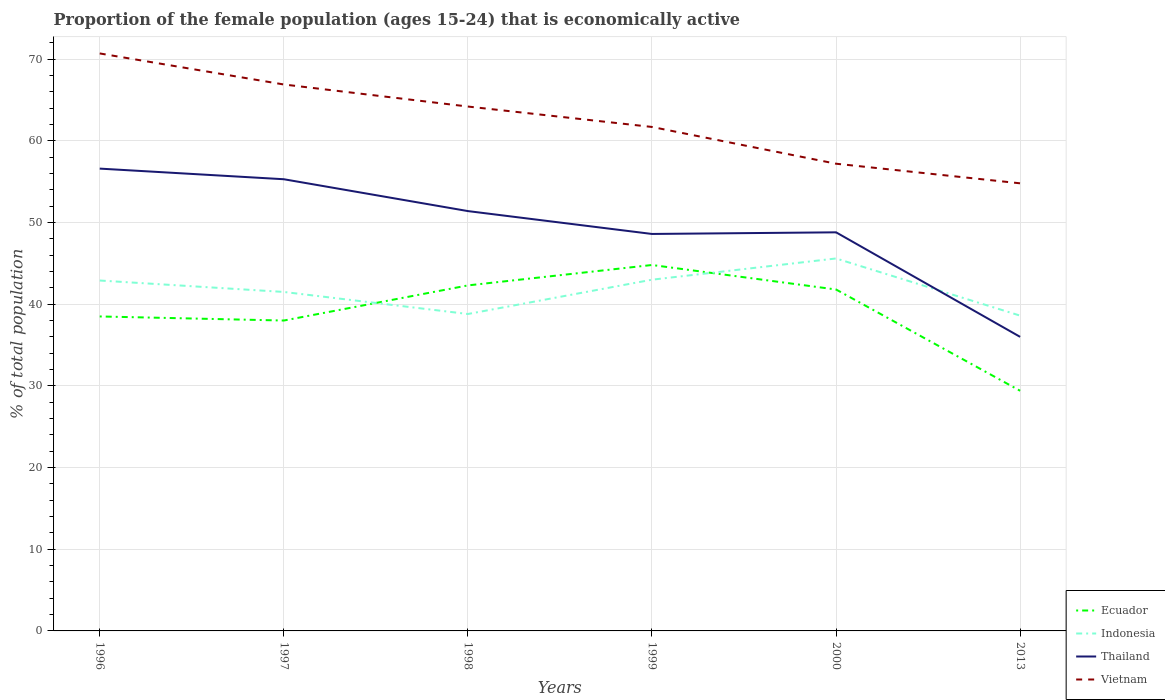Is the number of lines equal to the number of legend labels?
Ensure brevity in your answer.  Yes. Across all years, what is the maximum proportion of the female population that is economically active in Ecuador?
Provide a succinct answer. 29.4. What is the total proportion of the female population that is economically active in Ecuador in the graph?
Keep it short and to the point. -3.8. What is the difference between the highest and the second highest proportion of the female population that is economically active in Thailand?
Offer a very short reply. 20.6. How many years are there in the graph?
Provide a short and direct response. 6. What is the difference between two consecutive major ticks on the Y-axis?
Ensure brevity in your answer.  10. Are the values on the major ticks of Y-axis written in scientific E-notation?
Offer a very short reply. No. Does the graph contain any zero values?
Your answer should be compact. No. Where does the legend appear in the graph?
Offer a very short reply. Bottom right. What is the title of the graph?
Provide a succinct answer. Proportion of the female population (ages 15-24) that is economically active. Does "Macedonia" appear as one of the legend labels in the graph?
Provide a short and direct response. No. What is the label or title of the X-axis?
Provide a short and direct response. Years. What is the label or title of the Y-axis?
Ensure brevity in your answer.  % of total population. What is the % of total population in Ecuador in 1996?
Give a very brief answer. 38.5. What is the % of total population of Indonesia in 1996?
Your answer should be compact. 42.9. What is the % of total population in Thailand in 1996?
Your answer should be very brief. 56.6. What is the % of total population of Vietnam in 1996?
Provide a short and direct response. 70.7. What is the % of total population in Indonesia in 1997?
Make the answer very short. 41.5. What is the % of total population of Thailand in 1997?
Your response must be concise. 55.3. What is the % of total population in Vietnam in 1997?
Provide a succinct answer. 66.9. What is the % of total population in Ecuador in 1998?
Keep it short and to the point. 42.3. What is the % of total population of Indonesia in 1998?
Give a very brief answer. 38.8. What is the % of total population of Thailand in 1998?
Your response must be concise. 51.4. What is the % of total population of Vietnam in 1998?
Give a very brief answer. 64.2. What is the % of total population in Ecuador in 1999?
Your answer should be compact. 44.8. What is the % of total population of Indonesia in 1999?
Offer a terse response. 43. What is the % of total population of Thailand in 1999?
Ensure brevity in your answer.  48.6. What is the % of total population in Vietnam in 1999?
Your response must be concise. 61.7. What is the % of total population of Ecuador in 2000?
Your answer should be very brief. 41.8. What is the % of total population of Indonesia in 2000?
Make the answer very short. 45.6. What is the % of total population in Thailand in 2000?
Provide a short and direct response. 48.8. What is the % of total population in Vietnam in 2000?
Your answer should be compact. 57.2. What is the % of total population in Ecuador in 2013?
Provide a succinct answer. 29.4. What is the % of total population of Indonesia in 2013?
Offer a terse response. 38.6. What is the % of total population of Vietnam in 2013?
Make the answer very short. 54.8. Across all years, what is the maximum % of total population in Ecuador?
Make the answer very short. 44.8. Across all years, what is the maximum % of total population in Indonesia?
Keep it short and to the point. 45.6. Across all years, what is the maximum % of total population of Thailand?
Ensure brevity in your answer.  56.6. Across all years, what is the maximum % of total population of Vietnam?
Your response must be concise. 70.7. Across all years, what is the minimum % of total population of Ecuador?
Ensure brevity in your answer.  29.4. Across all years, what is the minimum % of total population in Indonesia?
Your answer should be very brief. 38.6. Across all years, what is the minimum % of total population in Vietnam?
Ensure brevity in your answer.  54.8. What is the total % of total population of Ecuador in the graph?
Make the answer very short. 234.8. What is the total % of total population in Indonesia in the graph?
Offer a terse response. 250.4. What is the total % of total population of Thailand in the graph?
Keep it short and to the point. 296.7. What is the total % of total population of Vietnam in the graph?
Keep it short and to the point. 375.5. What is the difference between the % of total population of Ecuador in 1996 and that in 1997?
Your answer should be very brief. 0.5. What is the difference between the % of total population in Indonesia in 1996 and that in 1997?
Provide a short and direct response. 1.4. What is the difference between the % of total population of Vietnam in 1996 and that in 1997?
Your answer should be compact. 3.8. What is the difference between the % of total population of Ecuador in 1996 and that in 1998?
Offer a terse response. -3.8. What is the difference between the % of total population of Indonesia in 1996 and that in 1998?
Give a very brief answer. 4.1. What is the difference between the % of total population in Thailand in 1996 and that in 1998?
Keep it short and to the point. 5.2. What is the difference between the % of total population of Vietnam in 1996 and that in 1998?
Your response must be concise. 6.5. What is the difference between the % of total population of Thailand in 1996 and that in 1999?
Ensure brevity in your answer.  8. What is the difference between the % of total population of Vietnam in 1996 and that in 1999?
Make the answer very short. 9. What is the difference between the % of total population of Indonesia in 1996 and that in 2000?
Ensure brevity in your answer.  -2.7. What is the difference between the % of total population of Indonesia in 1996 and that in 2013?
Provide a succinct answer. 4.3. What is the difference between the % of total population of Thailand in 1996 and that in 2013?
Your answer should be compact. 20.6. What is the difference between the % of total population in Indonesia in 1997 and that in 1998?
Offer a very short reply. 2.7. What is the difference between the % of total population in Ecuador in 1997 and that in 1999?
Offer a very short reply. -6.8. What is the difference between the % of total population in Thailand in 1997 and that in 1999?
Ensure brevity in your answer.  6.7. What is the difference between the % of total population in Thailand in 1997 and that in 2000?
Offer a very short reply. 6.5. What is the difference between the % of total population of Vietnam in 1997 and that in 2000?
Offer a very short reply. 9.7. What is the difference between the % of total population in Ecuador in 1997 and that in 2013?
Provide a succinct answer. 8.6. What is the difference between the % of total population of Thailand in 1997 and that in 2013?
Your answer should be compact. 19.3. What is the difference between the % of total population in Indonesia in 1998 and that in 1999?
Ensure brevity in your answer.  -4.2. What is the difference between the % of total population of Thailand in 1998 and that in 1999?
Your response must be concise. 2.8. What is the difference between the % of total population in Vietnam in 1998 and that in 1999?
Offer a very short reply. 2.5. What is the difference between the % of total population in Ecuador in 1998 and that in 2000?
Your response must be concise. 0.5. What is the difference between the % of total population in Vietnam in 1998 and that in 2000?
Ensure brevity in your answer.  7. What is the difference between the % of total population of Indonesia in 1998 and that in 2013?
Give a very brief answer. 0.2. What is the difference between the % of total population in Thailand in 1998 and that in 2013?
Your answer should be compact. 15.4. What is the difference between the % of total population in Ecuador in 1999 and that in 2000?
Provide a short and direct response. 3. What is the difference between the % of total population in Indonesia in 1999 and that in 2000?
Provide a short and direct response. -2.6. What is the difference between the % of total population of Thailand in 1999 and that in 2000?
Your response must be concise. -0.2. What is the difference between the % of total population of Vietnam in 1999 and that in 2000?
Offer a very short reply. 4.5. What is the difference between the % of total population of Indonesia in 1999 and that in 2013?
Provide a short and direct response. 4.4. What is the difference between the % of total population in Ecuador in 2000 and that in 2013?
Ensure brevity in your answer.  12.4. What is the difference between the % of total population of Ecuador in 1996 and the % of total population of Thailand in 1997?
Ensure brevity in your answer.  -16.8. What is the difference between the % of total population in Ecuador in 1996 and the % of total population in Vietnam in 1997?
Provide a short and direct response. -28.4. What is the difference between the % of total population of Indonesia in 1996 and the % of total population of Thailand in 1997?
Offer a very short reply. -12.4. What is the difference between the % of total population in Indonesia in 1996 and the % of total population in Vietnam in 1997?
Offer a very short reply. -24. What is the difference between the % of total population in Thailand in 1996 and the % of total population in Vietnam in 1997?
Make the answer very short. -10.3. What is the difference between the % of total population of Ecuador in 1996 and the % of total population of Indonesia in 1998?
Your answer should be compact. -0.3. What is the difference between the % of total population in Ecuador in 1996 and the % of total population in Vietnam in 1998?
Offer a very short reply. -25.7. What is the difference between the % of total population in Indonesia in 1996 and the % of total population in Thailand in 1998?
Provide a short and direct response. -8.5. What is the difference between the % of total population in Indonesia in 1996 and the % of total population in Vietnam in 1998?
Keep it short and to the point. -21.3. What is the difference between the % of total population of Thailand in 1996 and the % of total population of Vietnam in 1998?
Offer a very short reply. -7.6. What is the difference between the % of total population in Ecuador in 1996 and the % of total population in Indonesia in 1999?
Offer a very short reply. -4.5. What is the difference between the % of total population in Ecuador in 1996 and the % of total population in Vietnam in 1999?
Make the answer very short. -23.2. What is the difference between the % of total population in Indonesia in 1996 and the % of total population in Vietnam in 1999?
Offer a terse response. -18.8. What is the difference between the % of total population in Thailand in 1996 and the % of total population in Vietnam in 1999?
Your answer should be very brief. -5.1. What is the difference between the % of total population in Ecuador in 1996 and the % of total population in Vietnam in 2000?
Ensure brevity in your answer.  -18.7. What is the difference between the % of total population in Indonesia in 1996 and the % of total population in Vietnam in 2000?
Offer a very short reply. -14.3. What is the difference between the % of total population of Thailand in 1996 and the % of total population of Vietnam in 2000?
Make the answer very short. -0.6. What is the difference between the % of total population in Ecuador in 1996 and the % of total population in Vietnam in 2013?
Offer a terse response. -16.3. What is the difference between the % of total population of Indonesia in 1996 and the % of total population of Thailand in 2013?
Your answer should be very brief. 6.9. What is the difference between the % of total population in Indonesia in 1996 and the % of total population in Vietnam in 2013?
Offer a very short reply. -11.9. What is the difference between the % of total population in Ecuador in 1997 and the % of total population in Indonesia in 1998?
Your response must be concise. -0.8. What is the difference between the % of total population in Ecuador in 1997 and the % of total population in Thailand in 1998?
Provide a succinct answer. -13.4. What is the difference between the % of total population in Ecuador in 1997 and the % of total population in Vietnam in 1998?
Your answer should be compact. -26.2. What is the difference between the % of total population of Indonesia in 1997 and the % of total population of Thailand in 1998?
Ensure brevity in your answer.  -9.9. What is the difference between the % of total population of Indonesia in 1997 and the % of total population of Vietnam in 1998?
Offer a terse response. -22.7. What is the difference between the % of total population in Ecuador in 1997 and the % of total population in Vietnam in 1999?
Provide a short and direct response. -23.7. What is the difference between the % of total population in Indonesia in 1997 and the % of total population in Vietnam in 1999?
Give a very brief answer. -20.2. What is the difference between the % of total population of Ecuador in 1997 and the % of total population of Indonesia in 2000?
Provide a short and direct response. -7.6. What is the difference between the % of total population in Ecuador in 1997 and the % of total population in Vietnam in 2000?
Make the answer very short. -19.2. What is the difference between the % of total population in Indonesia in 1997 and the % of total population in Thailand in 2000?
Your answer should be compact. -7.3. What is the difference between the % of total population in Indonesia in 1997 and the % of total population in Vietnam in 2000?
Make the answer very short. -15.7. What is the difference between the % of total population in Thailand in 1997 and the % of total population in Vietnam in 2000?
Offer a very short reply. -1.9. What is the difference between the % of total population in Ecuador in 1997 and the % of total population in Indonesia in 2013?
Make the answer very short. -0.6. What is the difference between the % of total population in Ecuador in 1997 and the % of total population in Thailand in 2013?
Keep it short and to the point. 2. What is the difference between the % of total population of Ecuador in 1997 and the % of total population of Vietnam in 2013?
Ensure brevity in your answer.  -16.8. What is the difference between the % of total population in Indonesia in 1997 and the % of total population in Thailand in 2013?
Provide a succinct answer. 5.5. What is the difference between the % of total population of Indonesia in 1997 and the % of total population of Vietnam in 2013?
Your response must be concise. -13.3. What is the difference between the % of total population in Thailand in 1997 and the % of total population in Vietnam in 2013?
Keep it short and to the point. 0.5. What is the difference between the % of total population in Ecuador in 1998 and the % of total population in Vietnam in 1999?
Give a very brief answer. -19.4. What is the difference between the % of total population of Indonesia in 1998 and the % of total population of Thailand in 1999?
Keep it short and to the point. -9.8. What is the difference between the % of total population of Indonesia in 1998 and the % of total population of Vietnam in 1999?
Offer a terse response. -22.9. What is the difference between the % of total population of Ecuador in 1998 and the % of total population of Vietnam in 2000?
Your response must be concise. -14.9. What is the difference between the % of total population in Indonesia in 1998 and the % of total population in Vietnam in 2000?
Offer a terse response. -18.4. What is the difference between the % of total population of Ecuador in 1998 and the % of total population of Indonesia in 2013?
Give a very brief answer. 3.7. What is the difference between the % of total population in Ecuador in 1998 and the % of total population in Vietnam in 2013?
Your response must be concise. -12.5. What is the difference between the % of total population in Indonesia in 1998 and the % of total population in Thailand in 2013?
Give a very brief answer. 2.8. What is the difference between the % of total population in Indonesia in 1998 and the % of total population in Vietnam in 2013?
Make the answer very short. -16. What is the difference between the % of total population in Thailand in 1998 and the % of total population in Vietnam in 2013?
Ensure brevity in your answer.  -3.4. What is the difference between the % of total population of Ecuador in 1999 and the % of total population of Indonesia in 2000?
Provide a short and direct response. -0.8. What is the difference between the % of total population in Ecuador in 1999 and the % of total population in Vietnam in 2000?
Provide a short and direct response. -12.4. What is the difference between the % of total population in Indonesia in 1999 and the % of total population in Thailand in 2000?
Keep it short and to the point. -5.8. What is the difference between the % of total population in Thailand in 1999 and the % of total population in Vietnam in 2000?
Your response must be concise. -8.6. What is the difference between the % of total population of Ecuador in 2000 and the % of total population of Indonesia in 2013?
Your answer should be very brief. 3.2. What is the difference between the % of total population in Ecuador in 2000 and the % of total population in Thailand in 2013?
Make the answer very short. 5.8. What is the difference between the % of total population of Thailand in 2000 and the % of total population of Vietnam in 2013?
Your response must be concise. -6. What is the average % of total population in Ecuador per year?
Make the answer very short. 39.13. What is the average % of total population in Indonesia per year?
Make the answer very short. 41.73. What is the average % of total population in Thailand per year?
Ensure brevity in your answer.  49.45. What is the average % of total population of Vietnam per year?
Give a very brief answer. 62.58. In the year 1996, what is the difference between the % of total population in Ecuador and % of total population in Indonesia?
Provide a short and direct response. -4.4. In the year 1996, what is the difference between the % of total population in Ecuador and % of total population in Thailand?
Your answer should be very brief. -18.1. In the year 1996, what is the difference between the % of total population in Ecuador and % of total population in Vietnam?
Make the answer very short. -32.2. In the year 1996, what is the difference between the % of total population in Indonesia and % of total population in Thailand?
Keep it short and to the point. -13.7. In the year 1996, what is the difference between the % of total population in Indonesia and % of total population in Vietnam?
Your answer should be compact. -27.8. In the year 1996, what is the difference between the % of total population of Thailand and % of total population of Vietnam?
Keep it short and to the point. -14.1. In the year 1997, what is the difference between the % of total population of Ecuador and % of total population of Indonesia?
Your answer should be compact. -3.5. In the year 1997, what is the difference between the % of total population in Ecuador and % of total population in Thailand?
Your answer should be compact. -17.3. In the year 1997, what is the difference between the % of total population in Ecuador and % of total population in Vietnam?
Give a very brief answer. -28.9. In the year 1997, what is the difference between the % of total population of Indonesia and % of total population of Thailand?
Keep it short and to the point. -13.8. In the year 1997, what is the difference between the % of total population of Indonesia and % of total population of Vietnam?
Provide a short and direct response. -25.4. In the year 1998, what is the difference between the % of total population in Ecuador and % of total population in Vietnam?
Your response must be concise. -21.9. In the year 1998, what is the difference between the % of total population in Indonesia and % of total population in Vietnam?
Your response must be concise. -25.4. In the year 1998, what is the difference between the % of total population of Thailand and % of total population of Vietnam?
Offer a very short reply. -12.8. In the year 1999, what is the difference between the % of total population in Ecuador and % of total population in Vietnam?
Your answer should be compact. -16.9. In the year 1999, what is the difference between the % of total population in Indonesia and % of total population in Vietnam?
Keep it short and to the point. -18.7. In the year 1999, what is the difference between the % of total population of Thailand and % of total population of Vietnam?
Give a very brief answer. -13.1. In the year 2000, what is the difference between the % of total population in Ecuador and % of total population in Vietnam?
Your answer should be compact. -15.4. In the year 2000, what is the difference between the % of total population in Indonesia and % of total population in Thailand?
Your answer should be compact. -3.2. In the year 2013, what is the difference between the % of total population of Ecuador and % of total population of Indonesia?
Ensure brevity in your answer.  -9.2. In the year 2013, what is the difference between the % of total population of Ecuador and % of total population of Vietnam?
Offer a terse response. -25.4. In the year 2013, what is the difference between the % of total population in Indonesia and % of total population in Vietnam?
Offer a very short reply. -16.2. In the year 2013, what is the difference between the % of total population in Thailand and % of total population in Vietnam?
Provide a short and direct response. -18.8. What is the ratio of the % of total population of Ecuador in 1996 to that in 1997?
Provide a succinct answer. 1.01. What is the ratio of the % of total population in Indonesia in 1996 to that in 1997?
Offer a terse response. 1.03. What is the ratio of the % of total population of Thailand in 1996 to that in 1997?
Provide a succinct answer. 1.02. What is the ratio of the % of total population of Vietnam in 1996 to that in 1997?
Provide a short and direct response. 1.06. What is the ratio of the % of total population in Ecuador in 1996 to that in 1998?
Provide a short and direct response. 0.91. What is the ratio of the % of total population of Indonesia in 1996 to that in 1998?
Offer a terse response. 1.11. What is the ratio of the % of total population in Thailand in 1996 to that in 1998?
Offer a very short reply. 1.1. What is the ratio of the % of total population in Vietnam in 1996 to that in 1998?
Provide a succinct answer. 1.1. What is the ratio of the % of total population of Ecuador in 1996 to that in 1999?
Provide a succinct answer. 0.86. What is the ratio of the % of total population of Thailand in 1996 to that in 1999?
Your answer should be compact. 1.16. What is the ratio of the % of total population in Vietnam in 1996 to that in 1999?
Give a very brief answer. 1.15. What is the ratio of the % of total population in Ecuador in 1996 to that in 2000?
Give a very brief answer. 0.92. What is the ratio of the % of total population in Indonesia in 1996 to that in 2000?
Your answer should be very brief. 0.94. What is the ratio of the % of total population of Thailand in 1996 to that in 2000?
Your answer should be very brief. 1.16. What is the ratio of the % of total population in Vietnam in 1996 to that in 2000?
Your answer should be compact. 1.24. What is the ratio of the % of total population in Ecuador in 1996 to that in 2013?
Offer a very short reply. 1.31. What is the ratio of the % of total population in Indonesia in 1996 to that in 2013?
Keep it short and to the point. 1.11. What is the ratio of the % of total population in Thailand in 1996 to that in 2013?
Give a very brief answer. 1.57. What is the ratio of the % of total population in Vietnam in 1996 to that in 2013?
Give a very brief answer. 1.29. What is the ratio of the % of total population of Ecuador in 1997 to that in 1998?
Provide a succinct answer. 0.9. What is the ratio of the % of total population in Indonesia in 1997 to that in 1998?
Keep it short and to the point. 1.07. What is the ratio of the % of total population in Thailand in 1997 to that in 1998?
Give a very brief answer. 1.08. What is the ratio of the % of total population of Vietnam in 1997 to that in 1998?
Provide a succinct answer. 1.04. What is the ratio of the % of total population in Ecuador in 1997 to that in 1999?
Keep it short and to the point. 0.85. What is the ratio of the % of total population of Indonesia in 1997 to that in 1999?
Give a very brief answer. 0.97. What is the ratio of the % of total population of Thailand in 1997 to that in 1999?
Make the answer very short. 1.14. What is the ratio of the % of total population of Vietnam in 1997 to that in 1999?
Ensure brevity in your answer.  1.08. What is the ratio of the % of total population of Indonesia in 1997 to that in 2000?
Offer a terse response. 0.91. What is the ratio of the % of total population in Thailand in 1997 to that in 2000?
Your answer should be very brief. 1.13. What is the ratio of the % of total population of Vietnam in 1997 to that in 2000?
Make the answer very short. 1.17. What is the ratio of the % of total population in Ecuador in 1997 to that in 2013?
Provide a short and direct response. 1.29. What is the ratio of the % of total population in Indonesia in 1997 to that in 2013?
Your answer should be very brief. 1.08. What is the ratio of the % of total population of Thailand in 1997 to that in 2013?
Your response must be concise. 1.54. What is the ratio of the % of total population of Vietnam in 1997 to that in 2013?
Your answer should be very brief. 1.22. What is the ratio of the % of total population in Ecuador in 1998 to that in 1999?
Make the answer very short. 0.94. What is the ratio of the % of total population of Indonesia in 1998 to that in 1999?
Give a very brief answer. 0.9. What is the ratio of the % of total population in Thailand in 1998 to that in 1999?
Your answer should be very brief. 1.06. What is the ratio of the % of total population of Vietnam in 1998 to that in 1999?
Your answer should be very brief. 1.04. What is the ratio of the % of total population of Ecuador in 1998 to that in 2000?
Give a very brief answer. 1.01. What is the ratio of the % of total population of Indonesia in 1998 to that in 2000?
Offer a very short reply. 0.85. What is the ratio of the % of total population of Thailand in 1998 to that in 2000?
Provide a short and direct response. 1.05. What is the ratio of the % of total population of Vietnam in 1998 to that in 2000?
Provide a succinct answer. 1.12. What is the ratio of the % of total population of Ecuador in 1998 to that in 2013?
Provide a short and direct response. 1.44. What is the ratio of the % of total population of Indonesia in 1998 to that in 2013?
Ensure brevity in your answer.  1.01. What is the ratio of the % of total population of Thailand in 1998 to that in 2013?
Provide a short and direct response. 1.43. What is the ratio of the % of total population of Vietnam in 1998 to that in 2013?
Offer a very short reply. 1.17. What is the ratio of the % of total population of Ecuador in 1999 to that in 2000?
Offer a terse response. 1.07. What is the ratio of the % of total population of Indonesia in 1999 to that in 2000?
Offer a very short reply. 0.94. What is the ratio of the % of total population of Vietnam in 1999 to that in 2000?
Keep it short and to the point. 1.08. What is the ratio of the % of total population in Ecuador in 1999 to that in 2013?
Your answer should be compact. 1.52. What is the ratio of the % of total population in Indonesia in 1999 to that in 2013?
Make the answer very short. 1.11. What is the ratio of the % of total population of Thailand in 1999 to that in 2013?
Your answer should be very brief. 1.35. What is the ratio of the % of total population in Vietnam in 1999 to that in 2013?
Offer a terse response. 1.13. What is the ratio of the % of total population of Ecuador in 2000 to that in 2013?
Make the answer very short. 1.42. What is the ratio of the % of total population in Indonesia in 2000 to that in 2013?
Offer a terse response. 1.18. What is the ratio of the % of total population in Thailand in 2000 to that in 2013?
Make the answer very short. 1.36. What is the ratio of the % of total population of Vietnam in 2000 to that in 2013?
Your response must be concise. 1.04. What is the difference between the highest and the second highest % of total population of Indonesia?
Offer a terse response. 2.6. What is the difference between the highest and the second highest % of total population in Thailand?
Make the answer very short. 1.3. What is the difference between the highest and the lowest % of total population in Ecuador?
Make the answer very short. 15.4. What is the difference between the highest and the lowest % of total population of Indonesia?
Ensure brevity in your answer.  7. What is the difference between the highest and the lowest % of total population of Thailand?
Your response must be concise. 20.6. What is the difference between the highest and the lowest % of total population of Vietnam?
Provide a short and direct response. 15.9. 